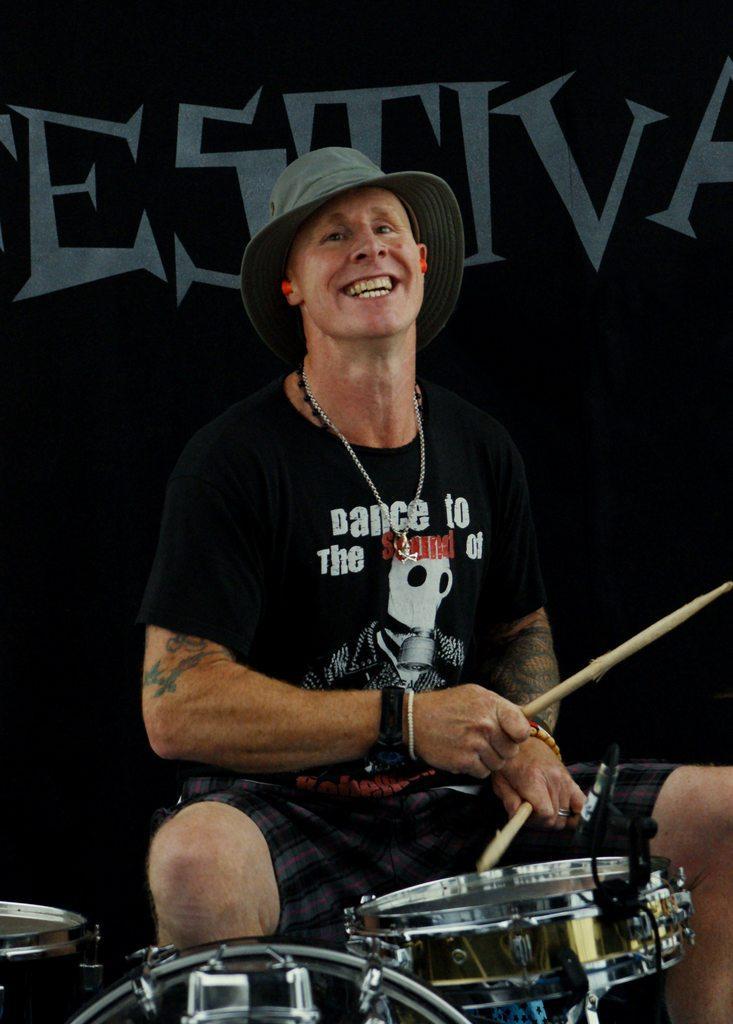In one or two sentences, can you explain what this image depicts? This is the picture of a man in black t shirt with a hat sitting on chair and holding drum sticks in front of the man there are music instrument. Behind the man there is a black banner. 